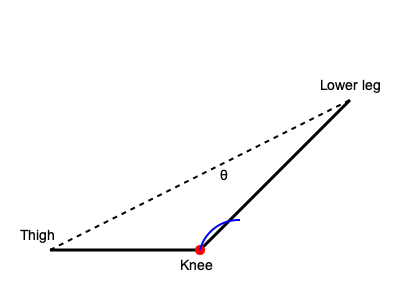During a leg extension exercise, a physiotherapist observes that the angle between a patient's thigh and lower leg is 60°. If the patient needs to increase this angle by 25% to achieve the proper form, what should be the final angle of the knee joint? To solve this problem, we'll follow these steps:

1. Identify the initial angle:
   The initial angle between the thigh and lower leg is 60°.

2. Calculate the increase:
   We need to increase this angle by 25%.
   
   Increase = 25% of 60°
   $$ \text{Increase} = 0.25 \times 60° = 15° $$

3. Calculate the final angle:
   Add the increase to the initial angle.
   
   $$ \text{Final angle} = \text{Initial angle} + \text{Increase} $$
   $$ \text{Final angle} = 60° + 15° = 75° $$

Therefore, the final angle of the knee joint should be 75°.
Answer: 75° 